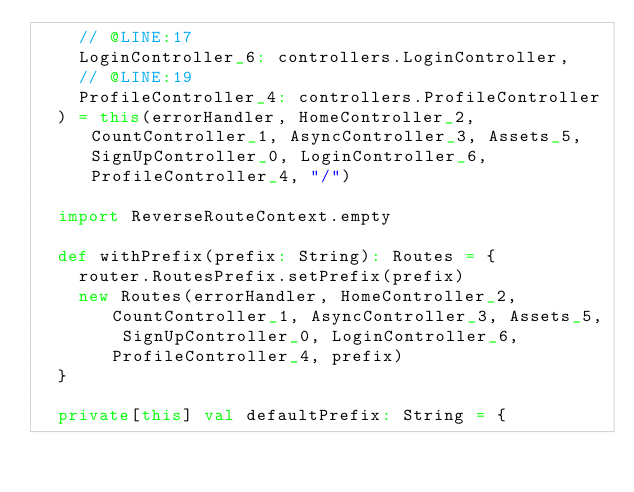<code> <loc_0><loc_0><loc_500><loc_500><_Scala_>    // @LINE:17
    LoginController_6: controllers.LoginController,
    // @LINE:19
    ProfileController_4: controllers.ProfileController
  ) = this(errorHandler, HomeController_2, CountController_1, AsyncController_3, Assets_5, SignUpController_0, LoginController_6, ProfileController_4, "/")

  import ReverseRouteContext.empty

  def withPrefix(prefix: String): Routes = {
    router.RoutesPrefix.setPrefix(prefix)
    new Routes(errorHandler, HomeController_2, CountController_1, AsyncController_3, Assets_5, SignUpController_0, LoginController_6, ProfileController_4, prefix)
  }

  private[this] val defaultPrefix: String = {</code> 